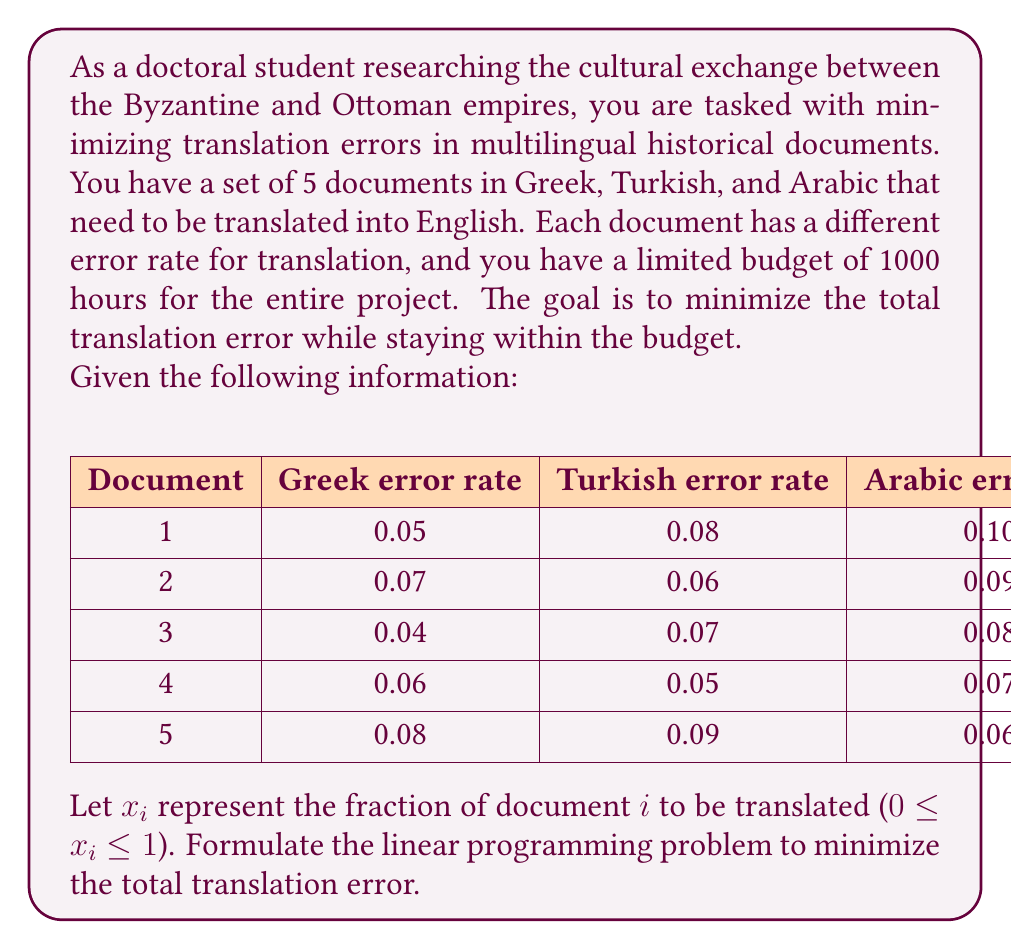Help me with this question. To formulate this linear programming problem, we need to define the objective function and constraints:

1. Objective function:
The goal is to minimize the total translation error. For each document, we'll use the minimum error rate among the three languages. The objective function is:

$$\text{Minimize } Z = 0.05x_1 + 0.06x_2 + 0.04x_3 + 0.05x_4 + 0.06x_5$$

2. Constraints:
a) Budget constraint: The total hours used should not exceed 1000.
$$200x_1 + 250x_2 + 300x_3 + 150x_4 + 100x_5 \leq 1000$$

b) Fraction constraints: Each $x_i$ should be between 0 and 1.
$$0 \leq x_i \leq 1 \text{ for } i = 1, 2, 3, 4, 5$$

3. Non-negativity constraints:
$$x_i \geq 0 \text{ for } i = 1, 2, 3, 4, 5$$

Putting it all together, the complete linear programming problem is:

$$\text{Minimize } Z = 0.05x_1 + 0.06x_2 + 0.04x_3 + 0.05x_4 + 0.06x_5$$

Subject to:
$$200x_1 + 250x_2 + 300x_3 + 150x_4 + 100x_5 \leq 1000$$
$$0 \leq x_i \leq 1 \text{ for } i = 1, 2, 3, 4, 5$$
$$x_i \geq 0 \text{ for } i = 1, 2, 3, 4, 5$$

This formulation allows for partial translation of documents, which might be necessary to stay within the budget while minimizing errors.
Answer: $$\begin{array}{l}
\text{Minimize } Z = 0.05x_1 + 0.06x_2 + 0.04x_3 + 0.05x_4 + 0.06x_5 \\
\text{Subject to:} \\
200x_1 + 250x_2 + 300x_3 + 150x_4 + 100x_5 \leq 1000 \\
0 \leq x_i \leq 1, \; x_i \geq 0 \text{ for } i = 1, 2, 3, 4, 5
\end{array}$$ 